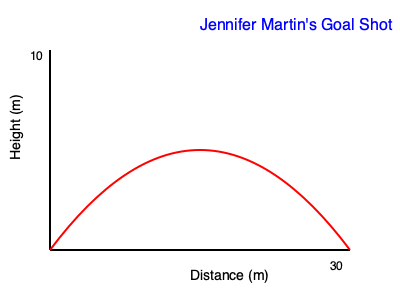The graph shows the trajectory of Jennifer Martin's goal-scoring shot in a recent match. If the initial velocity of the ball is 20 m/s and it reaches a maximum height of 10 meters, what is the approximate angle of elevation at which Jennifer kicked the ball? To find the angle of elevation, we can use the equation for the maximum height of a projectile:

1. The equation for maximum height is: $h_{max} = \frac{v_0^2 \sin^2 \theta}{2g}$

2. We know:
   - $h_{max} = 10$ meters
   - $v_0 = 20$ m/s (initial velocity)
   - $g = 9.8$ m/s² (acceleration due to gravity)

3. Substituting these values into the equation:
   $10 = \frac{20^2 \sin^2 \theta}{2(9.8)}$

4. Simplifying:
   $10 = \frac{400 \sin^2 \theta}{19.6}$

5. Multiplying both sides by 19.6:
   $196 = 400 \sin^2 \theta$

6. Dividing both sides by 400:
   $0.49 = \sin^2 \theta$

7. Taking the square root of both sides:
   $\sqrt{0.49} = \sin \theta$
   $0.7 = \sin \theta$

8. Taking the inverse sine (arcsin) of both sides:
   $\theta = \arcsin(0.7)$

9. Calculate:
   $\theta \approx 44.4°$

Therefore, Jennifer Martin kicked the ball at an angle of approximately 44° to the horizontal.
Answer: 44° 